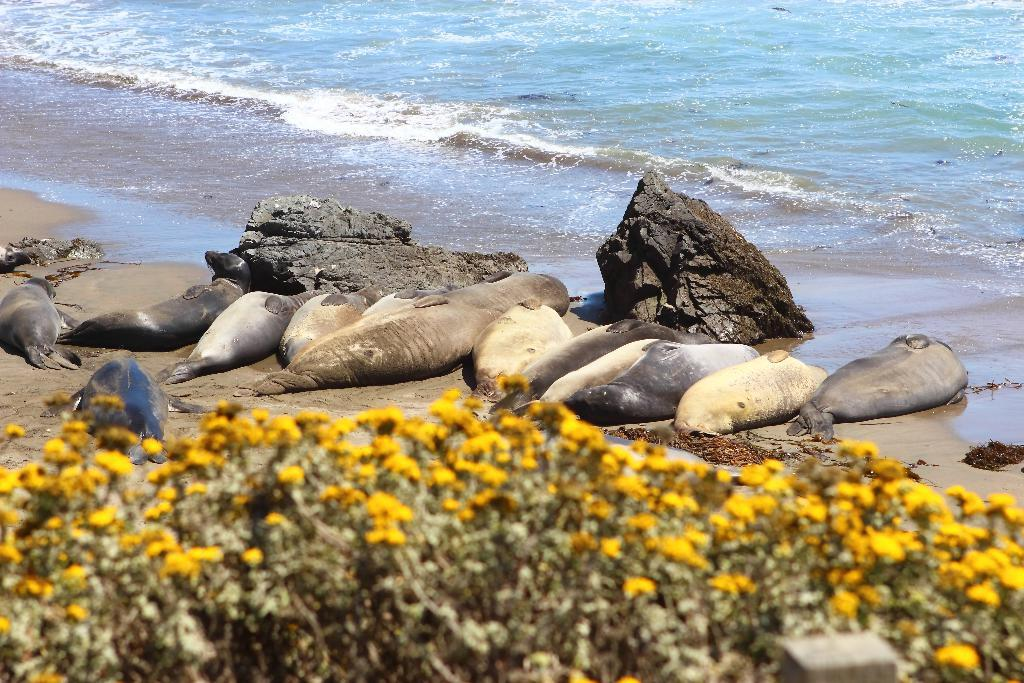What type of plants are at the bottom of the image? There are plants with flowers at the bottom of the image. What can be seen behind the plants in the image? There are seals on the seashore behind the plants. What type of natural formation is visible in the image? There are rocks visible in the image. What is present at the bottom of the image along with the plants? There is water at the bottom of the image. What type of scale can be seen in the image? There is no scale present in the image. Can you describe the girl sitting on the rocks in the image? There is no girl present in the image; it features plants, seals, rocks, and water. 